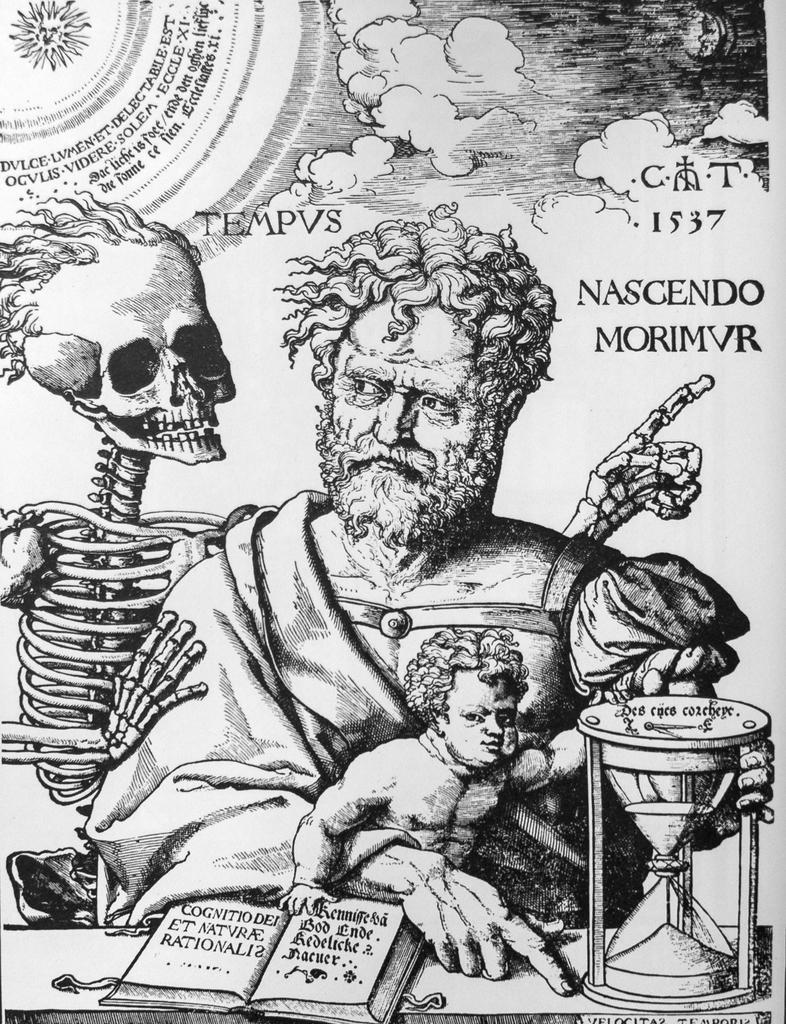Can you describe this image briefly? This image consists of a poster with a few images and there is text on it. At the bottom of the image there is a table with a book and a sand timer on it. At the top of the image there is a sky with clouds. In the middle of the image there is a man, a kid and a skeleton. 